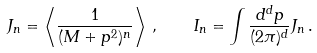Convert formula to latex. <formula><loc_0><loc_0><loc_500><loc_500>J _ { n } = \left \langle \frac { 1 } { ( M + p ^ { 2 } ) ^ { n } } \right \rangle \, , \quad I _ { n } = \int \frac { d ^ { d } p } { ( 2 \pi ) ^ { d } } J _ { n } \, .</formula> 